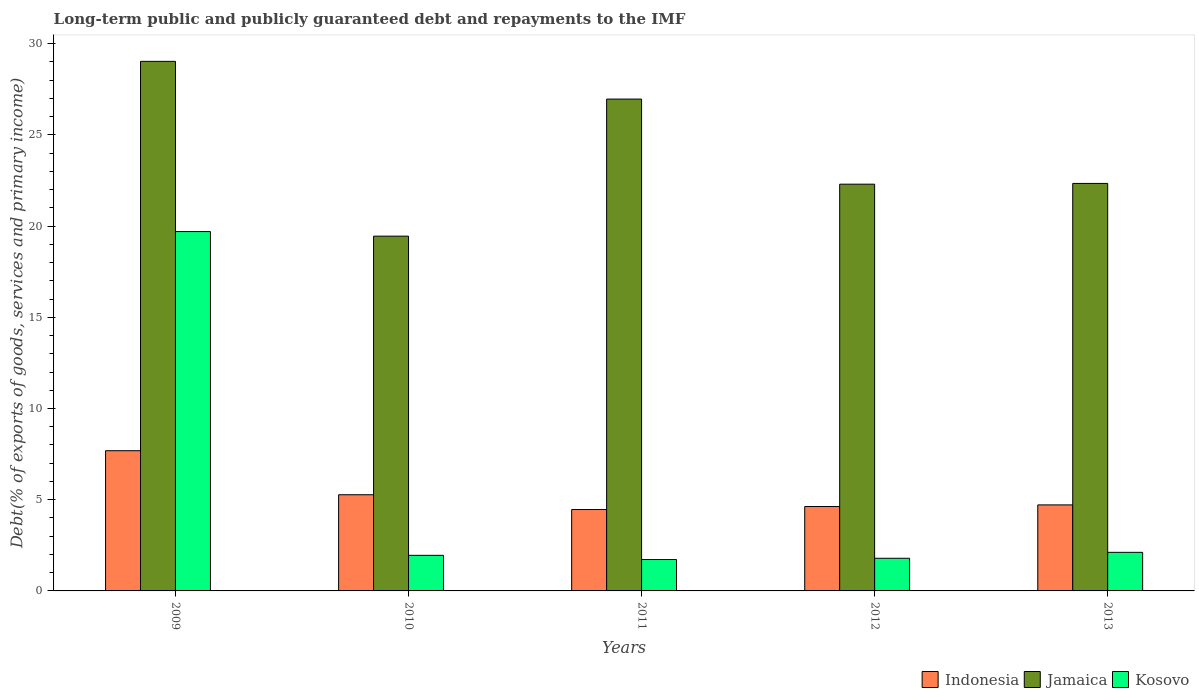How many different coloured bars are there?
Provide a succinct answer. 3. How many groups of bars are there?
Your response must be concise. 5. In how many cases, is the number of bars for a given year not equal to the number of legend labels?
Your response must be concise. 0. What is the debt and repayments in Kosovo in 2012?
Your answer should be very brief. 1.79. Across all years, what is the maximum debt and repayments in Kosovo?
Give a very brief answer. 19.7. Across all years, what is the minimum debt and repayments in Indonesia?
Ensure brevity in your answer.  4.46. In which year was the debt and repayments in Kosovo minimum?
Provide a short and direct response. 2011. What is the total debt and repayments in Indonesia in the graph?
Your answer should be very brief. 26.77. What is the difference between the debt and repayments in Jamaica in 2012 and that in 2013?
Your answer should be compact. -0.04. What is the difference between the debt and repayments in Jamaica in 2011 and the debt and repayments in Indonesia in 2010?
Your answer should be compact. 21.69. What is the average debt and repayments in Jamaica per year?
Provide a short and direct response. 24.02. In the year 2009, what is the difference between the debt and repayments in Indonesia and debt and repayments in Jamaica?
Your response must be concise. -21.35. In how many years, is the debt and repayments in Jamaica greater than 28 %?
Your answer should be compact. 1. What is the ratio of the debt and repayments in Jamaica in 2011 to that in 2013?
Provide a succinct answer. 1.21. Is the debt and repayments in Jamaica in 2012 less than that in 2013?
Provide a short and direct response. Yes. What is the difference between the highest and the second highest debt and repayments in Kosovo?
Keep it short and to the point. 17.59. What is the difference between the highest and the lowest debt and repayments in Kosovo?
Offer a terse response. 17.98. In how many years, is the debt and repayments in Jamaica greater than the average debt and repayments in Jamaica taken over all years?
Ensure brevity in your answer.  2. Is the sum of the debt and repayments in Indonesia in 2011 and 2013 greater than the maximum debt and repayments in Jamaica across all years?
Make the answer very short. No. What does the 3rd bar from the left in 2010 represents?
Your answer should be compact. Kosovo. What does the 1st bar from the right in 2011 represents?
Provide a succinct answer. Kosovo. Is it the case that in every year, the sum of the debt and repayments in Kosovo and debt and repayments in Indonesia is greater than the debt and repayments in Jamaica?
Provide a succinct answer. No. What is the difference between two consecutive major ticks on the Y-axis?
Your answer should be compact. 5. Are the values on the major ticks of Y-axis written in scientific E-notation?
Make the answer very short. No. Where does the legend appear in the graph?
Provide a succinct answer. Bottom right. How many legend labels are there?
Keep it short and to the point. 3. How are the legend labels stacked?
Ensure brevity in your answer.  Horizontal. What is the title of the graph?
Your answer should be very brief. Long-term public and publicly guaranteed debt and repayments to the IMF. What is the label or title of the Y-axis?
Make the answer very short. Debt(% of exports of goods, services and primary income). What is the Debt(% of exports of goods, services and primary income) in Indonesia in 2009?
Make the answer very short. 7.69. What is the Debt(% of exports of goods, services and primary income) in Jamaica in 2009?
Offer a terse response. 29.03. What is the Debt(% of exports of goods, services and primary income) in Kosovo in 2009?
Ensure brevity in your answer.  19.7. What is the Debt(% of exports of goods, services and primary income) of Indonesia in 2010?
Provide a succinct answer. 5.27. What is the Debt(% of exports of goods, services and primary income) in Jamaica in 2010?
Provide a short and direct response. 19.45. What is the Debt(% of exports of goods, services and primary income) in Kosovo in 2010?
Offer a terse response. 1.95. What is the Debt(% of exports of goods, services and primary income) in Indonesia in 2011?
Your answer should be very brief. 4.46. What is the Debt(% of exports of goods, services and primary income) of Jamaica in 2011?
Your answer should be compact. 26.97. What is the Debt(% of exports of goods, services and primary income) of Kosovo in 2011?
Offer a very short reply. 1.72. What is the Debt(% of exports of goods, services and primary income) in Indonesia in 2012?
Your answer should be compact. 4.63. What is the Debt(% of exports of goods, services and primary income) in Jamaica in 2012?
Provide a succinct answer. 22.3. What is the Debt(% of exports of goods, services and primary income) in Kosovo in 2012?
Provide a succinct answer. 1.79. What is the Debt(% of exports of goods, services and primary income) of Indonesia in 2013?
Give a very brief answer. 4.72. What is the Debt(% of exports of goods, services and primary income) in Jamaica in 2013?
Give a very brief answer. 22.34. What is the Debt(% of exports of goods, services and primary income) of Kosovo in 2013?
Offer a terse response. 2.12. Across all years, what is the maximum Debt(% of exports of goods, services and primary income) in Indonesia?
Ensure brevity in your answer.  7.69. Across all years, what is the maximum Debt(% of exports of goods, services and primary income) of Jamaica?
Your answer should be very brief. 29.03. Across all years, what is the maximum Debt(% of exports of goods, services and primary income) in Kosovo?
Provide a short and direct response. 19.7. Across all years, what is the minimum Debt(% of exports of goods, services and primary income) of Indonesia?
Provide a succinct answer. 4.46. Across all years, what is the minimum Debt(% of exports of goods, services and primary income) in Jamaica?
Your response must be concise. 19.45. Across all years, what is the minimum Debt(% of exports of goods, services and primary income) in Kosovo?
Offer a terse response. 1.72. What is the total Debt(% of exports of goods, services and primary income) in Indonesia in the graph?
Offer a very short reply. 26.77. What is the total Debt(% of exports of goods, services and primary income) of Jamaica in the graph?
Offer a terse response. 120.09. What is the total Debt(% of exports of goods, services and primary income) in Kosovo in the graph?
Keep it short and to the point. 27.28. What is the difference between the Debt(% of exports of goods, services and primary income) of Indonesia in 2009 and that in 2010?
Your response must be concise. 2.41. What is the difference between the Debt(% of exports of goods, services and primary income) in Jamaica in 2009 and that in 2010?
Ensure brevity in your answer.  9.58. What is the difference between the Debt(% of exports of goods, services and primary income) of Kosovo in 2009 and that in 2010?
Ensure brevity in your answer.  17.75. What is the difference between the Debt(% of exports of goods, services and primary income) in Indonesia in 2009 and that in 2011?
Make the answer very short. 3.22. What is the difference between the Debt(% of exports of goods, services and primary income) of Jamaica in 2009 and that in 2011?
Provide a short and direct response. 2.07. What is the difference between the Debt(% of exports of goods, services and primary income) of Kosovo in 2009 and that in 2011?
Keep it short and to the point. 17.98. What is the difference between the Debt(% of exports of goods, services and primary income) of Indonesia in 2009 and that in 2012?
Your response must be concise. 3.06. What is the difference between the Debt(% of exports of goods, services and primary income) of Jamaica in 2009 and that in 2012?
Ensure brevity in your answer.  6.73. What is the difference between the Debt(% of exports of goods, services and primary income) in Kosovo in 2009 and that in 2012?
Offer a very short reply. 17.91. What is the difference between the Debt(% of exports of goods, services and primary income) of Indonesia in 2009 and that in 2013?
Your response must be concise. 2.97. What is the difference between the Debt(% of exports of goods, services and primary income) in Jamaica in 2009 and that in 2013?
Your answer should be compact. 6.69. What is the difference between the Debt(% of exports of goods, services and primary income) in Kosovo in 2009 and that in 2013?
Give a very brief answer. 17.59. What is the difference between the Debt(% of exports of goods, services and primary income) of Indonesia in 2010 and that in 2011?
Provide a short and direct response. 0.81. What is the difference between the Debt(% of exports of goods, services and primary income) in Jamaica in 2010 and that in 2011?
Give a very brief answer. -7.52. What is the difference between the Debt(% of exports of goods, services and primary income) of Kosovo in 2010 and that in 2011?
Your answer should be compact. 0.23. What is the difference between the Debt(% of exports of goods, services and primary income) in Indonesia in 2010 and that in 2012?
Provide a short and direct response. 0.65. What is the difference between the Debt(% of exports of goods, services and primary income) in Jamaica in 2010 and that in 2012?
Keep it short and to the point. -2.85. What is the difference between the Debt(% of exports of goods, services and primary income) in Kosovo in 2010 and that in 2012?
Offer a terse response. 0.16. What is the difference between the Debt(% of exports of goods, services and primary income) in Indonesia in 2010 and that in 2013?
Ensure brevity in your answer.  0.56. What is the difference between the Debt(% of exports of goods, services and primary income) in Jamaica in 2010 and that in 2013?
Your answer should be very brief. -2.89. What is the difference between the Debt(% of exports of goods, services and primary income) of Kosovo in 2010 and that in 2013?
Give a very brief answer. -0.16. What is the difference between the Debt(% of exports of goods, services and primary income) of Indonesia in 2011 and that in 2012?
Offer a terse response. -0.16. What is the difference between the Debt(% of exports of goods, services and primary income) of Jamaica in 2011 and that in 2012?
Keep it short and to the point. 4.67. What is the difference between the Debt(% of exports of goods, services and primary income) of Kosovo in 2011 and that in 2012?
Offer a very short reply. -0.07. What is the difference between the Debt(% of exports of goods, services and primary income) of Indonesia in 2011 and that in 2013?
Offer a very short reply. -0.25. What is the difference between the Debt(% of exports of goods, services and primary income) in Jamaica in 2011 and that in 2013?
Your response must be concise. 4.62. What is the difference between the Debt(% of exports of goods, services and primary income) in Kosovo in 2011 and that in 2013?
Provide a succinct answer. -0.39. What is the difference between the Debt(% of exports of goods, services and primary income) of Indonesia in 2012 and that in 2013?
Provide a succinct answer. -0.09. What is the difference between the Debt(% of exports of goods, services and primary income) in Jamaica in 2012 and that in 2013?
Offer a very short reply. -0.04. What is the difference between the Debt(% of exports of goods, services and primary income) of Kosovo in 2012 and that in 2013?
Keep it short and to the point. -0.33. What is the difference between the Debt(% of exports of goods, services and primary income) in Indonesia in 2009 and the Debt(% of exports of goods, services and primary income) in Jamaica in 2010?
Your response must be concise. -11.76. What is the difference between the Debt(% of exports of goods, services and primary income) in Indonesia in 2009 and the Debt(% of exports of goods, services and primary income) in Kosovo in 2010?
Give a very brief answer. 5.74. What is the difference between the Debt(% of exports of goods, services and primary income) of Jamaica in 2009 and the Debt(% of exports of goods, services and primary income) of Kosovo in 2010?
Offer a very short reply. 27.08. What is the difference between the Debt(% of exports of goods, services and primary income) in Indonesia in 2009 and the Debt(% of exports of goods, services and primary income) in Jamaica in 2011?
Provide a succinct answer. -19.28. What is the difference between the Debt(% of exports of goods, services and primary income) of Indonesia in 2009 and the Debt(% of exports of goods, services and primary income) of Kosovo in 2011?
Your answer should be very brief. 5.97. What is the difference between the Debt(% of exports of goods, services and primary income) of Jamaica in 2009 and the Debt(% of exports of goods, services and primary income) of Kosovo in 2011?
Make the answer very short. 27.31. What is the difference between the Debt(% of exports of goods, services and primary income) of Indonesia in 2009 and the Debt(% of exports of goods, services and primary income) of Jamaica in 2012?
Make the answer very short. -14.61. What is the difference between the Debt(% of exports of goods, services and primary income) in Indonesia in 2009 and the Debt(% of exports of goods, services and primary income) in Kosovo in 2012?
Offer a very short reply. 5.9. What is the difference between the Debt(% of exports of goods, services and primary income) of Jamaica in 2009 and the Debt(% of exports of goods, services and primary income) of Kosovo in 2012?
Provide a succinct answer. 27.24. What is the difference between the Debt(% of exports of goods, services and primary income) of Indonesia in 2009 and the Debt(% of exports of goods, services and primary income) of Jamaica in 2013?
Ensure brevity in your answer.  -14.65. What is the difference between the Debt(% of exports of goods, services and primary income) of Indonesia in 2009 and the Debt(% of exports of goods, services and primary income) of Kosovo in 2013?
Provide a succinct answer. 5.57. What is the difference between the Debt(% of exports of goods, services and primary income) in Jamaica in 2009 and the Debt(% of exports of goods, services and primary income) in Kosovo in 2013?
Your answer should be compact. 26.92. What is the difference between the Debt(% of exports of goods, services and primary income) of Indonesia in 2010 and the Debt(% of exports of goods, services and primary income) of Jamaica in 2011?
Offer a very short reply. -21.69. What is the difference between the Debt(% of exports of goods, services and primary income) of Indonesia in 2010 and the Debt(% of exports of goods, services and primary income) of Kosovo in 2011?
Offer a terse response. 3.55. What is the difference between the Debt(% of exports of goods, services and primary income) in Jamaica in 2010 and the Debt(% of exports of goods, services and primary income) in Kosovo in 2011?
Provide a short and direct response. 17.73. What is the difference between the Debt(% of exports of goods, services and primary income) of Indonesia in 2010 and the Debt(% of exports of goods, services and primary income) of Jamaica in 2012?
Keep it short and to the point. -17.03. What is the difference between the Debt(% of exports of goods, services and primary income) in Indonesia in 2010 and the Debt(% of exports of goods, services and primary income) in Kosovo in 2012?
Provide a succinct answer. 3.48. What is the difference between the Debt(% of exports of goods, services and primary income) in Jamaica in 2010 and the Debt(% of exports of goods, services and primary income) in Kosovo in 2012?
Offer a very short reply. 17.66. What is the difference between the Debt(% of exports of goods, services and primary income) in Indonesia in 2010 and the Debt(% of exports of goods, services and primary income) in Jamaica in 2013?
Make the answer very short. -17.07. What is the difference between the Debt(% of exports of goods, services and primary income) in Indonesia in 2010 and the Debt(% of exports of goods, services and primary income) in Kosovo in 2013?
Ensure brevity in your answer.  3.16. What is the difference between the Debt(% of exports of goods, services and primary income) of Jamaica in 2010 and the Debt(% of exports of goods, services and primary income) of Kosovo in 2013?
Offer a very short reply. 17.33. What is the difference between the Debt(% of exports of goods, services and primary income) in Indonesia in 2011 and the Debt(% of exports of goods, services and primary income) in Jamaica in 2012?
Your answer should be compact. -17.84. What is the difference between the Debt(% of exports of goods, services and primary income) of Indonesia in 2011 and the Debt(% of exports of goods, services and primary income) of Kosovo in 2012?
Provide a short and direct response. 2.67. What is the difference between the Debt(% of exports of goods, services and primary income) in Jamaica in 2011 and the Debt(% of exports of goods, services and primary income) in Kosovo in 2012?
Your answer should be compact. 25.18. What is the difference between the Debt(% of exports of goods, services and primary income) of Indonesia in 2011 and the Debt(% of exports of goods, services and primary income) of Jamaica in 2013?
Provide a succinct answer. -17.88. What is the difference between the Debt(% of exports of goods, services and primary income) of Indonesia in 2011 and the Debt(% of exports of goods, services and primary income) of Kosovo in 2013?
Your answer should be compact. 2.35. What is the difference between the Debt(% of exports of goods, services and primary income) of Jamaica in 2011 and the Debt(% of exports of goods, services and primary income) of Kosovo in 2013?
Offer a very short reply. 24.85. What is the difference between the Debt(% of exports of goods, services and primary income) of Indonesia in 2012 and the Debt(% of exports of goods, services and primary income) of Jamaica in 2013?
Your response must be concise. -17.71. What is the difference between the Debt(% of exports of goods, services and primary income) in Indonesia in 2012 and the Debt(% of exports of goods, services and primary income) in Kosovo in 2013?
Provide a short and direct response. 2.51. What is the difference between the Debt(% of exports of goods, services and primary income) in Jamaica in 2012 and the Debt(% of exports of goods, services and primary income) in Kosovo in 2013?
Ensure brevity in your answer.  20.18. What is the average Debt(% of exports of goods, services and primary income) in Indonesia per year?
Ensure brevity in your answer.  5.35. What is the average Debt(% of exports of goods, services and primary income) of Jamaica per year?
Provide a succinct answer. 24.02. What is the average Debt(% of exports of goods, services and primary income) of Kosovo per year?
Your answer should be very brief. 5.46. In the year 2009, what is the difference between the Debt(% of exports of goods, services and primary income) in Indonesia and Debt(% of exports of goods, services and primary income) in Jamaica?
Provide a short and direct response. -21.35. In the year 2009, what is the difference between the Debt(% of exports of goods, services and primary income) of Indonesia and Debt(% of exports of goods, services and primary income) of Kosovo?
Your answer should be compact. -12.02. In the year 2009, what is the difference between the Debt(% of exports of goods, services and primary income) in Jamaica and Debt(% of exports of goods, services and primary income) in Kosovo?
Keep it short and to the point. 9.33. In the year 2010, what is the difference between the Debt(% of exports of goods, services and primary income) in Indonesia and Debt(% of exports of goods, services and primary income) in Jamaica?
Your answer should be very brief. -14.18. In the year 2010, what is the difference between the Debt(% of exports of goods, services and primary income) in Indonesia and Debt(% of exports of goods, services and primary income) in Kosovo?
Provide a succinct answer. 3.32. In the year 2010, what is the difference between the Debt(% of exports of goods, services and primary income) in Jamaica and Debt(% of exports of goods, services and primary income) in Kosovo?
Make the answer very short. 17.5. In the year 2011, what is the difference between the Debt(% of exports of goods, services and primary income) of Indonesia and Debt(% of exports of goods, services and primary income) of Jamaica?
Keep it short and to the point. -22.5. In the year 2011, what is the difference between the Debt(% of exports of goods, services and primary income) in Indonesia and Debt(% of exports of goods, services and primary income) in Kosovo?
Provide a succinct answer. 2.74. In the year 2011, what is the difference between the Debt(% of exports of goods, services and primary income) of Jamaica and Debt(% of exports of goods, services and primary income) of Kosovo?
Ensure brevity in your answer.  25.24. In the year 2012, what is the difference between the Debt(% of exports of goods, services and primary income) in Indonesia and Debt(% of exports of goods, services and primary income) in Jamaica?
Offer a very short reply. -17.67. In the year 2012, what is the difference between the Debt(% of exports of goods, services and primary income) in Indonesia and Debt(% of exports of goods, services and primary income) in Kosovo?
Offer a terse response. 2.84. In the year 2012, what is the difference between the Debt(% of exports of goods, services and primary income) in Jamaica and Debt(% of exports of goods, services and primary income) in Kosovo?
Keep it short and to the point. 20.51. In the year 2013, what is the difference between the Debt(% of exports of goods, services and primary income) in Indonesia and Debt(% of exports of goods, services and primary income) in Jamaica?
Make the answer very short. -17.62. In the year 2013, what is the difference between the Debt(% of exports of goods, services and primary income) in Indonesia and Debt(% of exports of goods, services and primary income) in Kosovo?
Provide a succinct answer. 2.6. In the year 2013, what is the difference between the Debt(% of exports of goods, services and primary income) in Jamaica and Debt(% of exports of goods, services and primary income) in Kosovo?
Keep it short and to the point. 20.23. What is the ratio of the Debt(% of exports of goods, services and primary income) of Indonesia in 2009 to that in 2010?
Your answer should be compact. 1.46. What is the ratio of the Debt(% of exports of goods, services and primary income) of Jamaica in 2009 to that in 2010?
Provide a short and direct response. 1.49. What is the ratio of the Debt(% of exports of goods, services and primary income) of Kosovo in 2009 to that in 2010?
Give a very brief answer. 10.1. What is the ratio of the Debt(% of exports of goods, services and primary income) of Indonesia in 2009 to that in 2011?
Provide a succinct answer. 1.72. What is the ratio of the Debt(% of exports of goods, services and primary income) in Jamaica in 2009 to that in 2011?
Offer a very short reply. 1.08. What is the ratio of the Debt(% of exports of goods, services and primary income) of Kosovo in 2009 to that in 2011?
Ensure brevity in your answer.  11.45. What is the ratio of the Debt(% of exports of goods, services and primary income) of Indonesia in 2009 to that in 2012?
Offer a terse response. 1.66. What is the ratio of the Debt(% of exports of goods, services and primary income) in Jamaica in 2009 to that in 2012?
Your answer should be compact. 1.3. What is the ratio of the Debt(% of exports of goods, services and primary income) of Kosovo in 2009 to that in 2012?
Offer a terse response. 11.01. What is the ratio of the Debt(% of exports of goods, services and primary income) of Indonesia in 2009 to that in 2013?
Your answer should be compact. 1.63. What is the ratio of the Debt(% of exports of goods, services and primary income) in Jamaica in 2009 to that in 2013?
Offer a very short reply. 1.3. What is the ratio of the Debt(% of exports of goods, services and primary income) in Kosovo in 2009 to that in 2013?
Provide a succinct answer. 9.32. What is the ratio of the Debt(% of exports of goods, services and primary income) in Indonesia in 2010 to that in 2011?
Ensure brevity in your answer.  1.18. What is the ratio of the Debt(% of exports of goods, services and primary income) of Jamaica in 2010 to that in 2011?
Provide a short and direct response. 0.72. What is the ratio of the Debt(% of exports of goods, services and primary income) of Kosovo in 2010 to that in 2011?
Your response must be concise. 1.13. What is the ratio of the Debt(% of exports of goods, services and primary income) of Indonesia in 2010 to that in 2012?
Keep it short and to the point. 1.14. What is the ratio of the Debt(% of exports of goods, services and primary income) of Jamaica in 2010 to that in 2012?
Your answer should be compact. 0.87. What is the ratio of the Debt(% of exports of goods, services and primary income) of Kosovo in 2010 to that in 2012?
Your answer should be very brief. 1.09. What is the ratio of the Debt(% of exports of goods, services and primary income) in Indonesia in 2010 to that in 2013?
Ensure brevity in your answer.  1.12. What is the ratio of the Debt(% of exports of goods, services and primary income) of Jamaica in 2010 to that in 2013?
Provide a succinct answer. 0.87. What is the ratio of the Debt(% of exports of goods, services and primary income) in Kosovo in 2010 to that in 2013?
Ensure brevity in your answer.  0.92. What is the ratio of the Debt(% of exports of goods, services and primary income) in Indonesia in 2011 to that in 2012?
Make the answer very short. 0.96. What is the ratio of the Debt(% of exports of goods, services and primary income) of Jamaica in 2011 to that in 2012?
Your response must be concise. 1.21. What is the ratio of the Debt(% of exports of goods, services and primary income) in Kosovo in 2011 to that in 2012?
Your response must be concise. 0.96. What is the ratio of the Debt(% of exports of goods, services and primary income) of Indonesia in 2011 to that in 2013?
Your answer should be compact. 0.95. What is the ratio of the Debt(% of exports of goods, services and primary income) in Jamaica in 2011 to that in 2013?
Offer a very short reply. 1.21. What is the ratio of the Debt(% of exports of goods, services and primary income) of Kosovo in 2011 to that in 2013?
Your response must be concise. 0.81. What is the ratio of the Debt(% of exports of goods, services and primary income) of Indonesia in 2012 to that in 2013?
Give a very brief answer. 0.98. What is the ratio of the Debt(% of exports of goods, services and primary income) in Kosovo in 2012 to that in 2013?
Your response must be concise. 0.85. What is the difference between the highest and the second highest Debt(% of exports of goods, services and primary income) in Indonesia?
Offer a terse response. 2.41. What is the difference between the highest and the second highest Debt(% of exports of goods, services and primary income) of Jamaica?
Your response must be concise. 2.07. What is the difference between the highest and the second highest Debt(% of exports of goods, services and primary income) of Kosovo?
Your response must be concise. 17.59. What is the difference between the highest and the lowest Debt(% of exports of goods, services and primary income) in Indonesia?
Ensure brevity in your answer.  3.22. What is the difference between the highest and the lowest Debt(% of exports of goods, services and primary income) of Jamaica?
Provide a short and direct response. 9.58. What is the difference between the highest and the lowest Debt(% of exports of goods, services and primary income) in Kosovo?
Give a very brief answer. 17.98. 